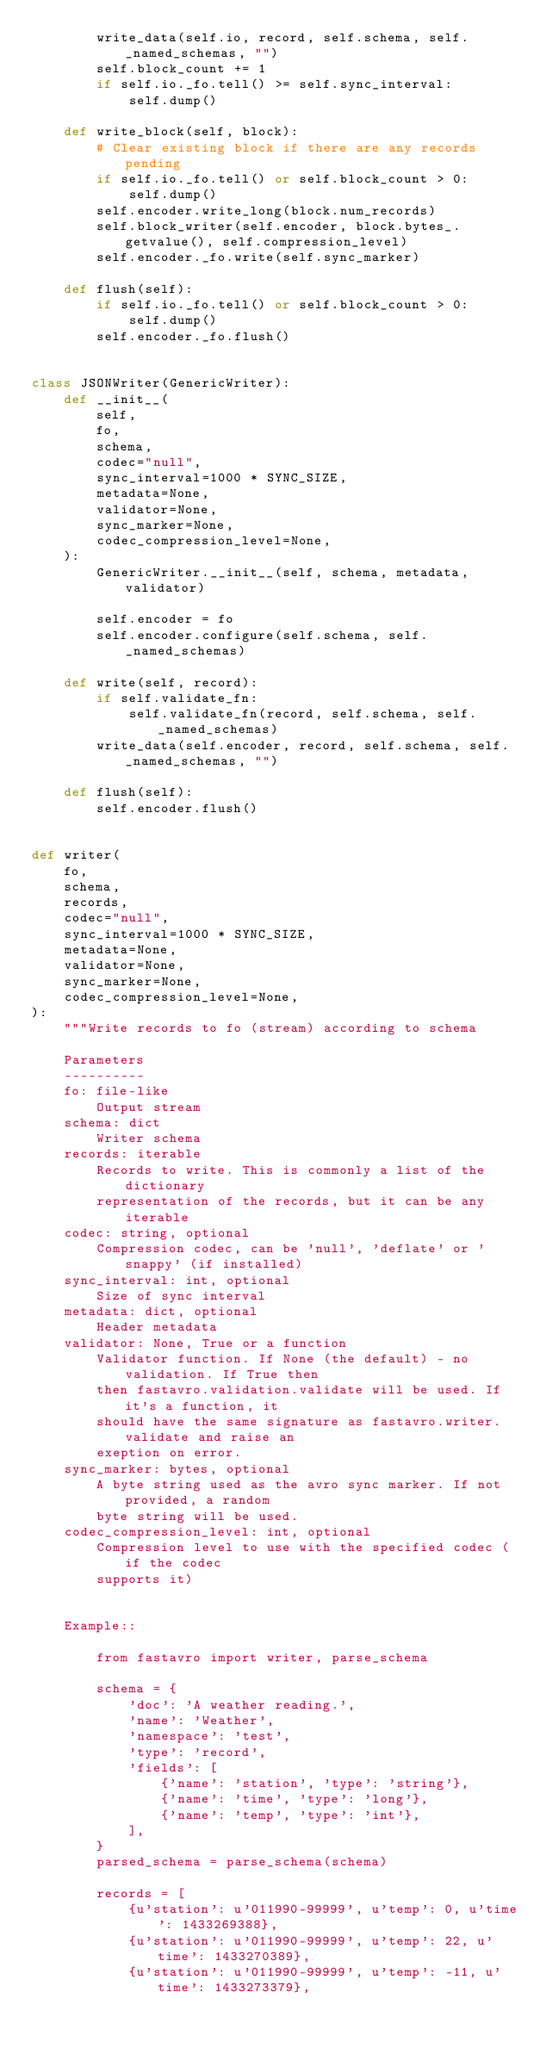<code> <loc_0><loc_0><loc_500><loc_500><_Python_>        write_data(self.io, record, self.schema, self._named_schemas, "")
        self.block_count += 1
        if self.io._fo.tell() >= self.sync_interval:
            self.dump()

    def write_block(self, block):
        # Clear existing block if there are any records pending
        if self.io._fo.tell() or self.block_count > 0:
            self.dump()
        self.encoder.write_long(block.num_records)
        self.block_writer(self.encoder, block.bytes_.getvalue(), self.compression_level)
        self.encoder._fo.write(self.sync_marker)

    def flush(self):
        if self.io._fo.tell() or self.block_count > 0:
            self.dump()
        self.encoder._fo.flush()


class JSONWriter(GenericWriter):
    def __init__(
        self,
        fo,
        schema,
        codec="null",
        sync_interval=1000 * SYNC_SIZE,
        metadata=None,
        validator=None,
        sync_marker=None,
        codec_compression_level=None,
    ):
        GenericWriter.__init__(self, schema, metadata, validator)

        self.encoder = fo
        self.encoder.configure(self.schema, self._named_schemas)

    def write(self, record):
        if self.validate_fn:
            self.validate_fn(record, self.schema, self._named_schemas)
        write_data(self.encoder, record, self.schema, self._named_schemas, "")

    def flush(self):
        self.encoder.flush()


def writer(
    fo,
    schema,
    records,
    codec="null",
    sync_interval=1000 * SYNC_SIZE,
    metadata=None,
    validator=None,
    sync_marker=None,
    codec_compression_level=None,
):
    """Write records to fo (stream) according to schema

    Parameters
    ----------
    fo: file-like
        Output stream
    schema: dict
        Writer schema
    records: iterable
        Records to write. This is commonly a list of the dictionary
        representation of the records, but it can be any iterable
    codec: string, optional
        Compression codec, can be 'null', 'deflate' or 'snappy' (if installed)
    sync_interval: int, optional
        Size of sync interval
    metadata: dict, optional
        Header metadata
    validator: None, True or a function
        Validator function. If None (the default) - no validation. If True then
        then fastavro.validation.validate will be used. If it's a function, it
        should have the same signature as fastavro.writer.validate and raise an
        exeption on error.
    sync_marker: bytes, optional
        A byte string used as the avro sync marker. If not provided, a random
        byte string will be used.
    codec_compression_level: int, optional
        Compression level to use with the specified codec (if the codec
        supports it)


    Example::

        from fastavro import writer, parse_schema

        schema = {
            'doc': 'A weather reading.',
            'name': 'Weather',
            'namespace': 'test',
            'type': 'record',
            'fields': [
                {'name': 'station', 'type': 'string'},
                {'name': 'time', 'type': 'long'},
                {'name': 'temp', 'type': 'int'},
            ],
        }
        parsed_schema = parse_schema(schema)

        records = [
            {u'station': u'011990-99999', u'temp': 0, u'time': 1433269388},
            {u'station': u'011990-99999', u'temp': 22, u'time': 1433270389},
            {u'station': u'011990-99999', u'temp': -11, u'time': 1433273379},</code> 